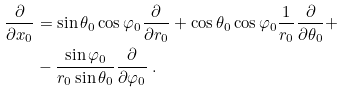Convert formula to latex. <formula><loc_0><loc_0><loc_500><loc_500>\frac { \partial } { \partial x _ { 0 } } & = \sin \theta _ { 0 } \cos \varphi _ { 0 } \frac { \partial } { \partial r _ { 0 } } + \cos \theta _ { 0 } \cos \varphi _ { 0 } \frac { 1 } { r _ { 0 } } \frac { \partial } { \partial \theta _ { 0 } } + \\ & - \frac { \sin \varphi _ { 0 } } { r _ { 0 } \sin \theta _ { 0 } } \frac { \partial } { \partial \varphi _ { 0 } } \ .</formula> 